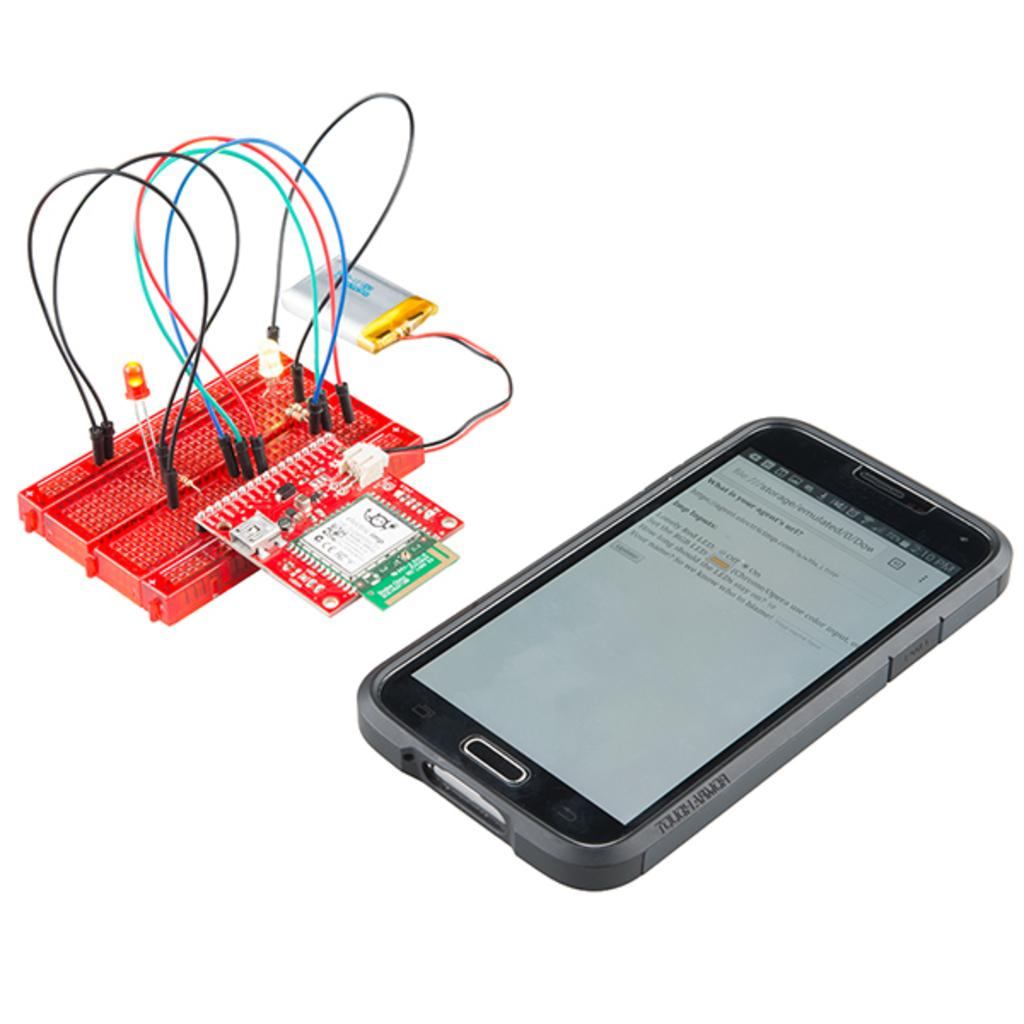<image>
Summarize the visual content of the image. A question on the screen of the cell phone asks what is your agent's url?. 